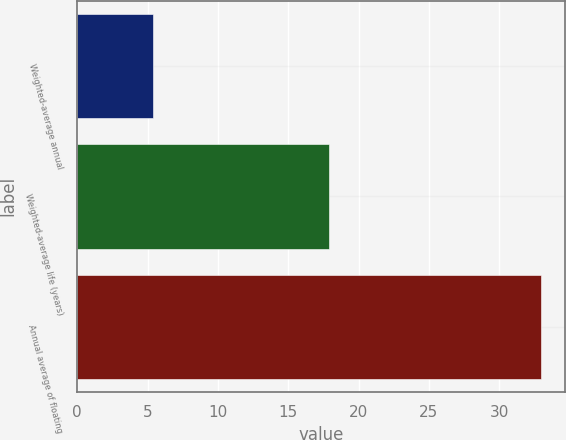<chart> <loc_0><loc_0><loc_500><loc_500><bar_chart><fcel>Weighted-average annual<fcel>Weighted-average life (years)<fcel>Annual average of floating<nl><fcel>5.4<fcel>17.9<fcel>33<nl></chart> 